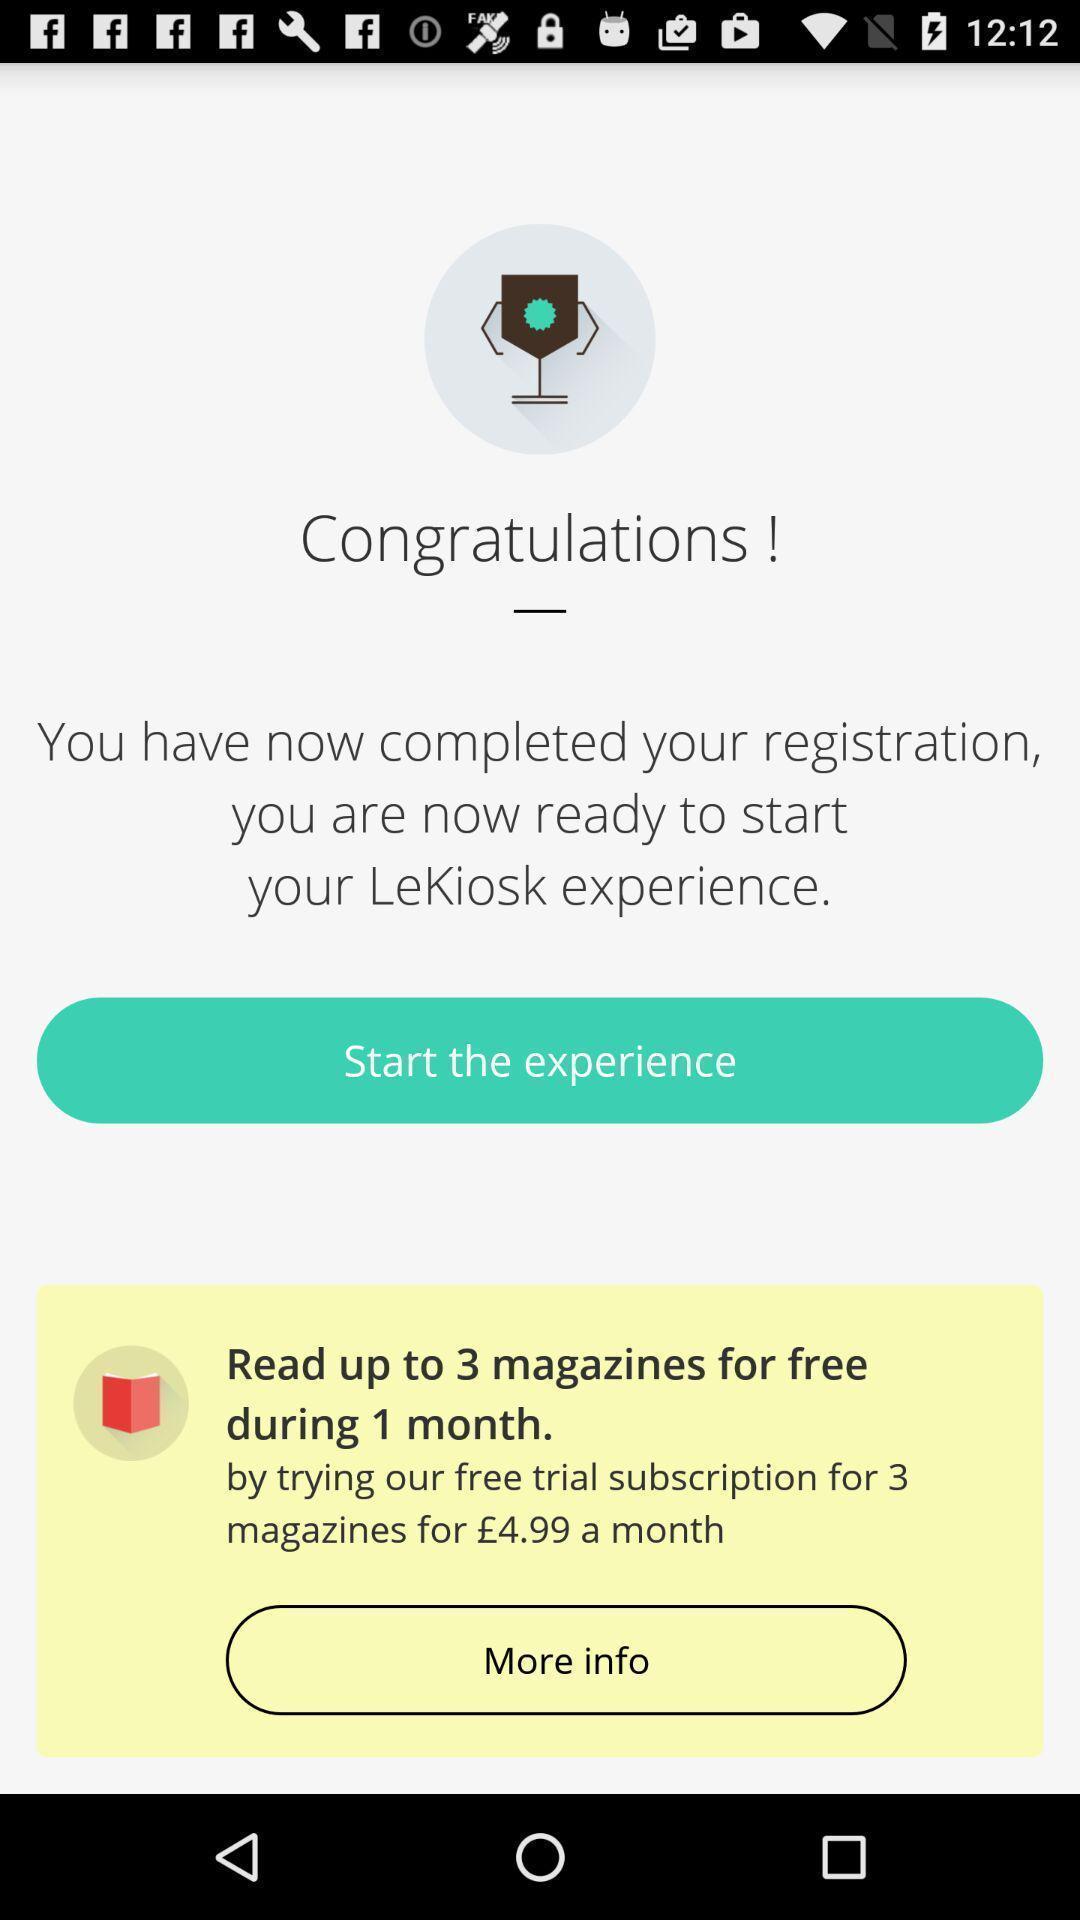Give me a narrative description of this picture. Welcome page. 